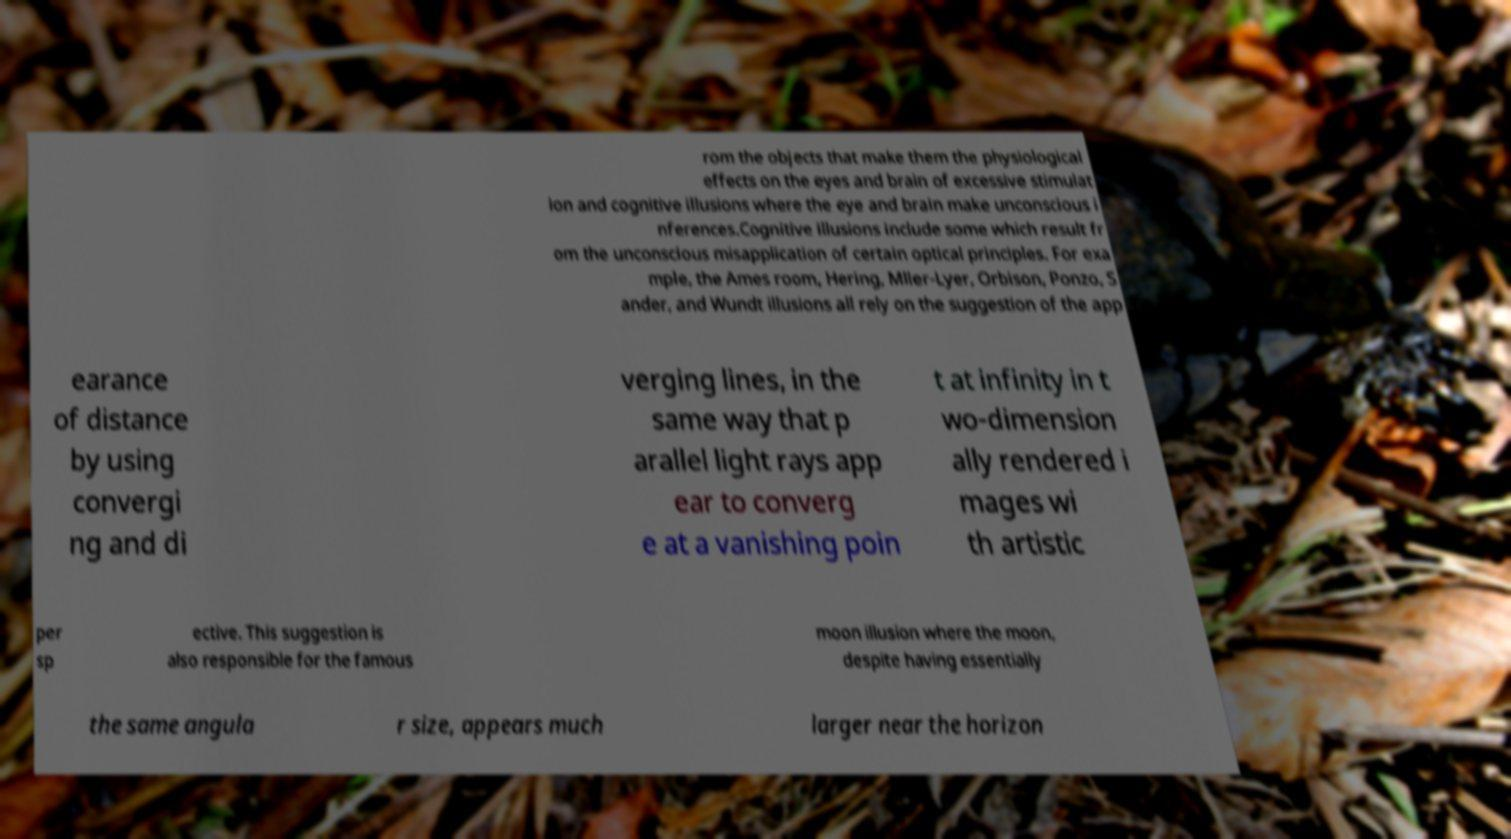Could you extract and type out the text from this image? rom the objects that make them the physiological effects on the eyes and brain of excessive stimulat ion and cognitive illusions where the eye and brain make unconscious i nferences.Cognitive illusions include some which result fr om the unconscious misapplication of certain optical principles. For exa mple, the Ames room, Hering, Mller-Lyer, Orbison, Ponzo, S ander, and Wundt illusions all rely on the suggestion of the app earance of distance by using convergi ng and di verging lines, in the same way that p arallel light rays app ear to converg e at a vanishing poin t at infinity in t wo-dimension ally rendered i mages wi th artistic per sp ective. This suggestion is also responsible for the famous moon illusion where the moon, despite having essentially the same angula r size, appears much larger near the horizon 